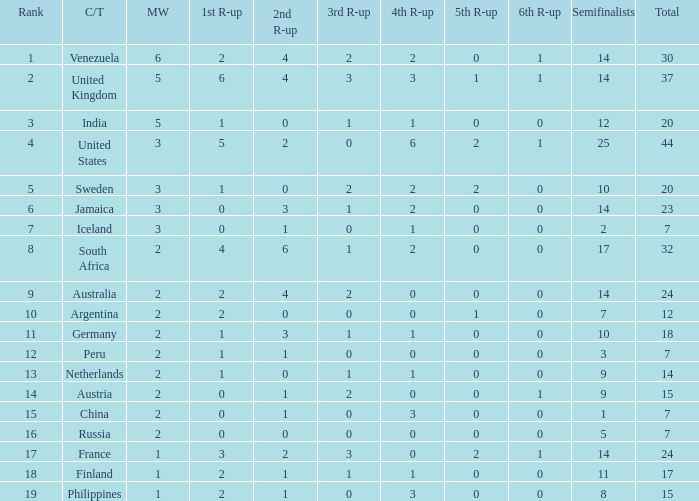What is Venezuela's total rank? 30.0. 